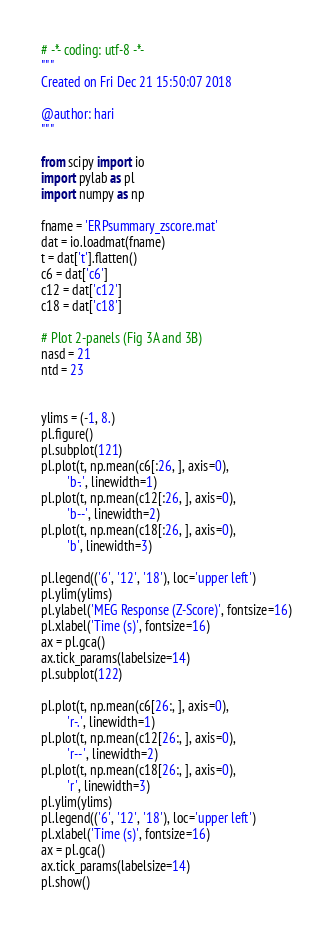<code> <loc_0><loc_0><loc_500><loc_500><_Python_># -*- coding: utf-8 -*-
"""
Created on Fri Dec 21 15:50:07 2018

@author: hari
"""

from scipy import io
import pylab as pl
import numpy as np

fname = 'ERPsummary_zscore.mat'
dat = io.loadmat(fname)
t = dat['t'].flatten()
c6 = dat['c6']
c12 = dat['c12']
c18 = dat['c18']

# Plot 2-panels (Fig 3A and 3B)
nasd = 21 
ntd = 23


ylims = (-1, 8.)
pl.figure()
pl.subplot(121)
pl.plot(t, np.mean(c6[:26, ], axis=0),
        'b-.', linewidth=1)
pl.plot(t, np.mean(c12[:26, ], axis=0),
        'b--', linewidth=2)
pl.plot(t, np.mean(c18[:26, ], axis=0),
        'b', linewidth=3)

pl.legend(('6', '12', '18'), loc='upper left')
pl.ylim(ylims)
pl.ylabel('MEG Response (Z-Score)', fontsize=16)
pl.xlabel('Time (s)', fontsize=16)
ax = pl.gca()
ax.tick_params(labelsize=14)
pl.subplot(122)

pl.plot(t, np.mean(c6[26:, ], axis=0),
        'r-.', linewidth=1)
pl.plot(t, np.mean(c12[26:, ], axis=0),
        'r--', linewidth=2)
pl.plot(t, np.mean(c18[26:, ], axis=0),
        'r', linewidth=3)
pl.ylim(ylims)
pl.legend(('6', '12', '18'), loc='upper left')
pl.xlabel('Time (s)', fontsize=16)
ax = pl.gca()
ax.tick_params(labelsize=14)
pl.show()</code> 